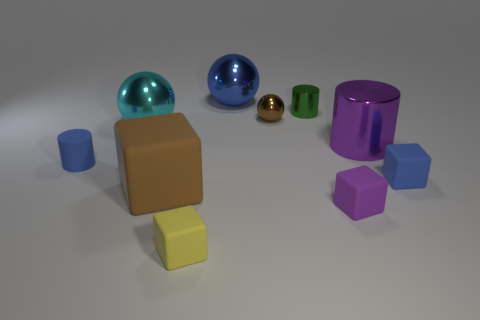Subtract all tiny rubber cylinders. How many cylinders are left? 2 Subtract 1 cylinders. How many cylinders are left? 2 Subtract all brown cubes. How many cubes are left? 3 Subtract all green balls. Subtract all red cylinders. How many balls are left? 3 Subtract all blocks. How many objects are left? 6 Subtract all small green metallic things. Subtract all green spheres. How many objects are left? 9 Add 1 small rubber cylinders. How many small rubber cylinders are left? 2 Add 3 cyan spheres. How many cyan spheres exist? 4 Subtract 1 blue blocks. How many objects are left? 9 